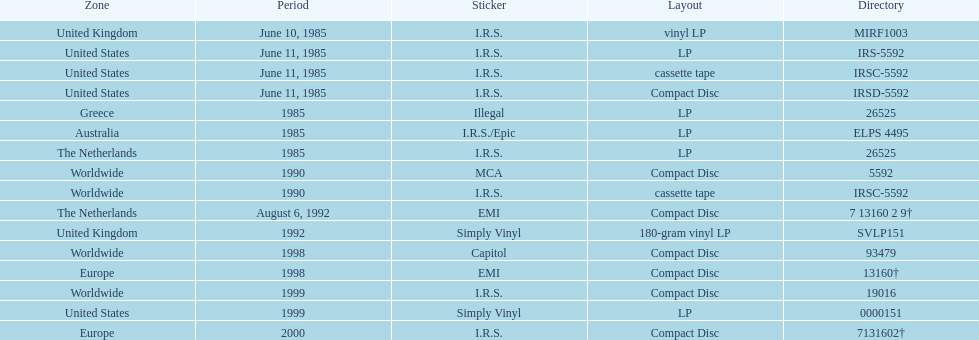How many more releases were in compact disc format than cassette tape? 5. 